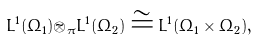<formula> <loc_0><loc_0><loc_500><loc_500>L ^ { 1 } ( \Omega _ { 1 } ) \tilde { \otimes } _ { \pi } L ^ { 1 } ( \Omega _ { 2 } ) \cong L ^ { 1 } ( \Omega _ { 1 } \times \Omega _ { 2 } ) ,</formula> 